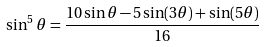<formula> <loc_0><loc_0><loc_500><loc_500>\sin ^ { 5 } \theta = { \frac { 1 0 \sin \theta - 5 \sin ( 3 \theta ) + \sin ( 5 \theta ) } { 1 6 } }</formula> 